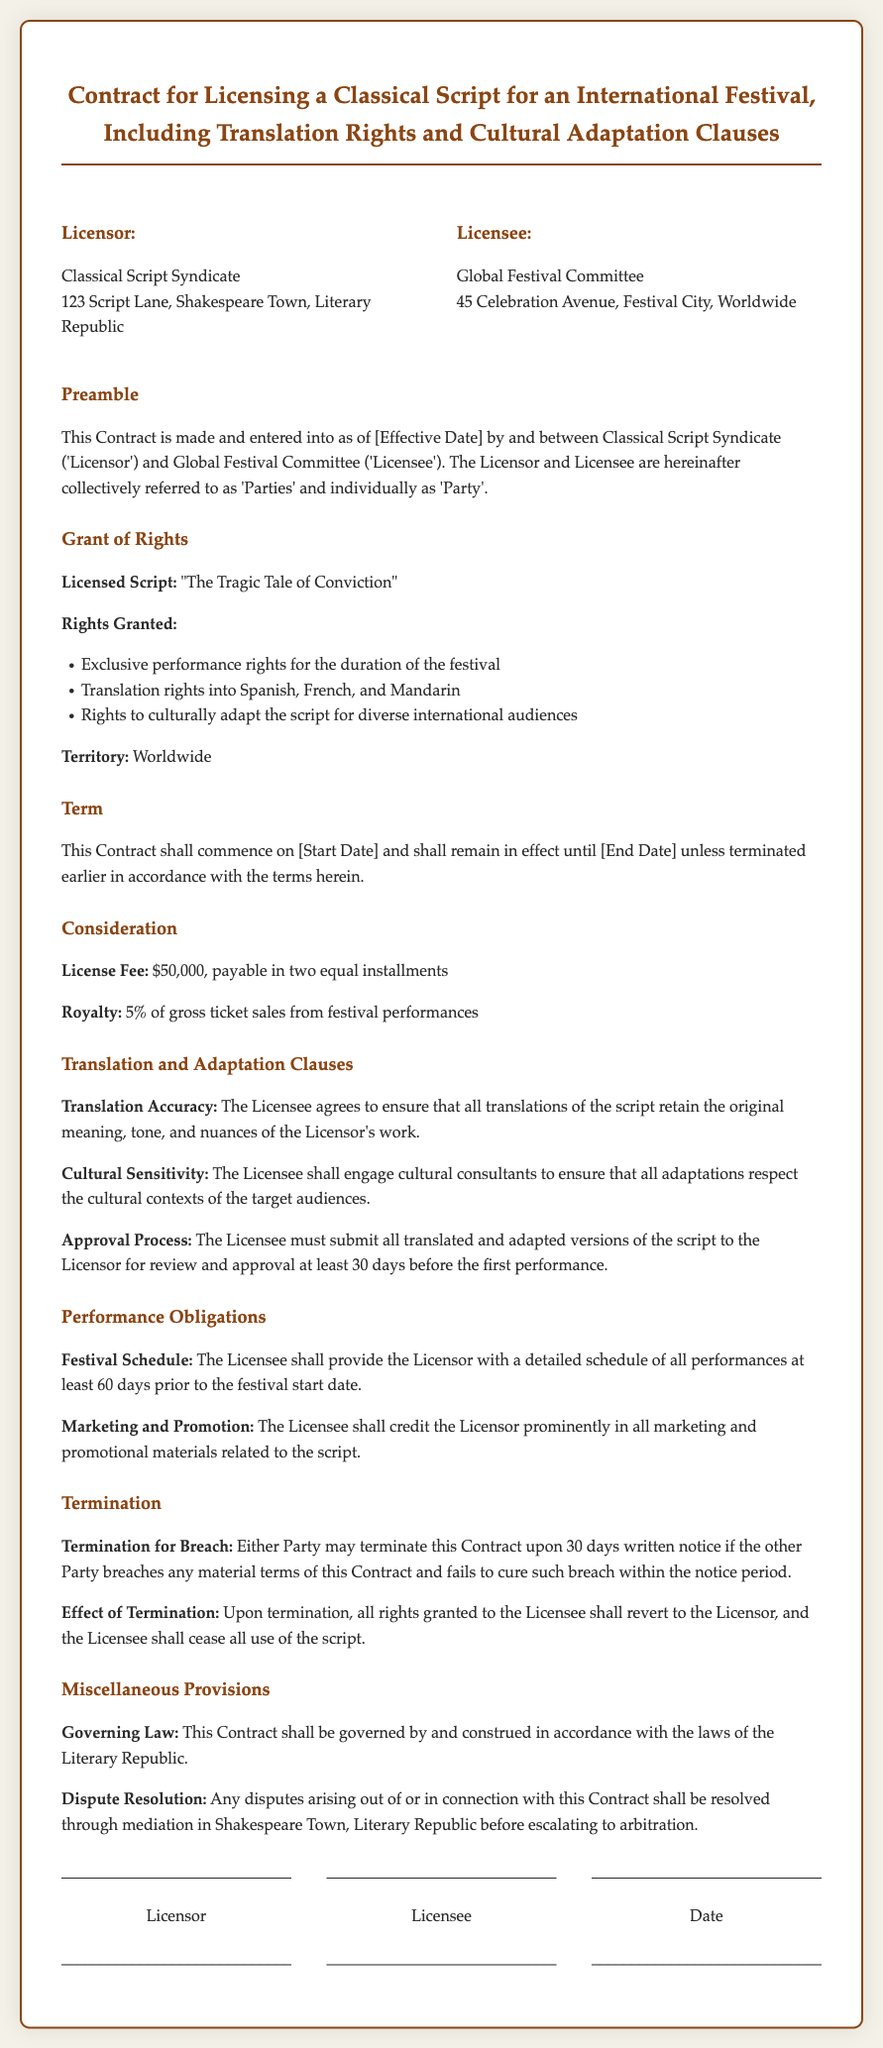What is the name of the licensed script? The licensed script is specified under the "Licensed Script" section as "The Tragic Tale of Conviction."
Answer: The Tragic Tale of Conviction Who is the Licensor? The Licensor is identified at the beginning of the contract.
Answer: Classical Script Syndicate What rights are granted for the script? The "Rights Granted" section lists various rights including exclusive performance rights and translation rights.
Answer: Exclusive performance rights, Translation rights into Spanish, French, and Mandarin What is the license fee? The license fee is mentioned under the "Consideration" section.
Answer: $50,000 How long must the Licensee submit adaptations for approval before the first performance? The "Approval Process" outlines the required time frame for submission of adaptations.
Answer: 30 days What is the royalty percentage from gross ticket sales? The royalty percentage is noted in the "Consideration" section specifically regarding gross ticket sales.
Answer: 5% Where must disputes be resolved? The "Dispute Resolution" section specifies the location for resolving disputes.
Answer: Shakespeare Town, Literary Republic What is the duration of the contract? The duration is stated in the "Term" section, referring to start and end dates outlined in the document.
Answer: [Start Date] to [End Date] 